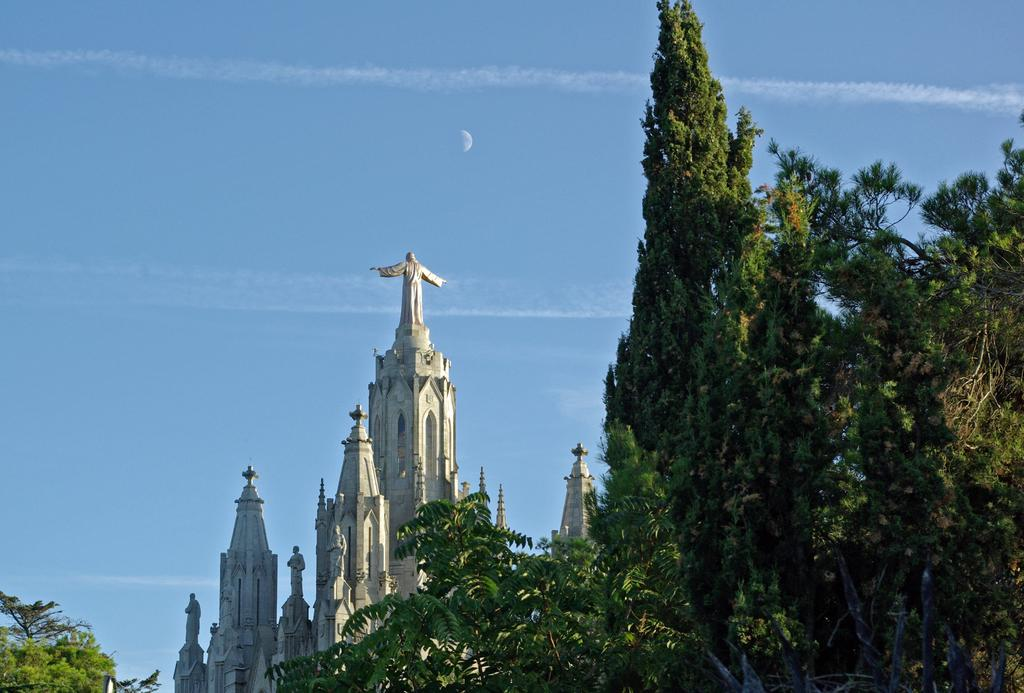What type of natural elements can be seen in the image? There are trees in the image. What type of building is present in the image? There is a church in the image. What decorative features are on top of the church? There are statues on top of the church. What is visible at the top of the image? The sky is visible at the top of the image and appears clear. Can you tell me what type of receipt is visible in the image? There is no receipt present in the image. How many pages of the book can be seen in the image? There is no book present in the image. 